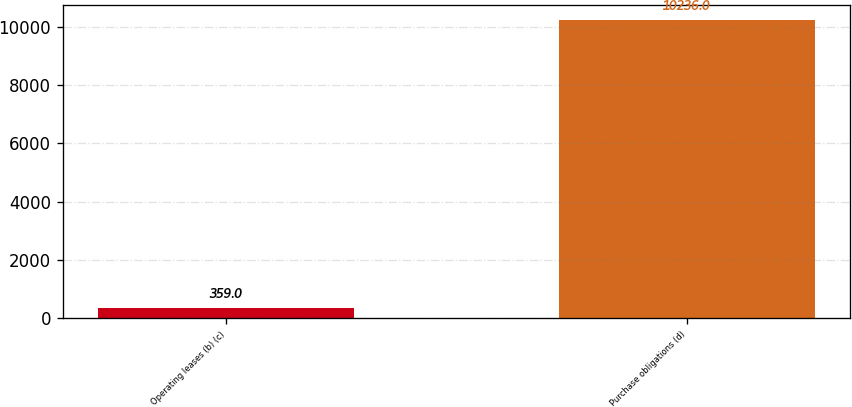<chart> <loc_0><loc_0><loc_500><loc_500><bar_chart><fcel>Operating leases (b) (c)<fcel>Purchase obligations (d)<nl><fcel>359<fcel>10236<nl></chart> 